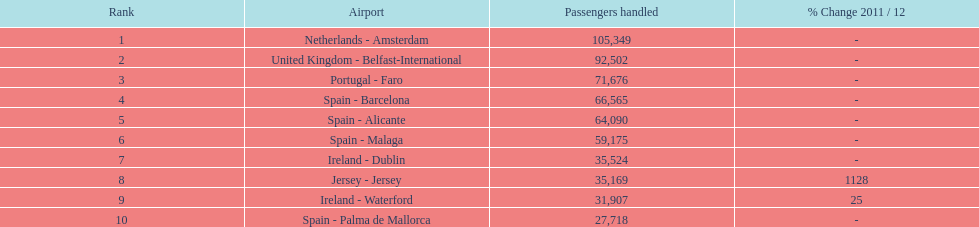Which airport experiences the least passenger flow in connection with london southend airport? Spain - Palma de Mallorca. 